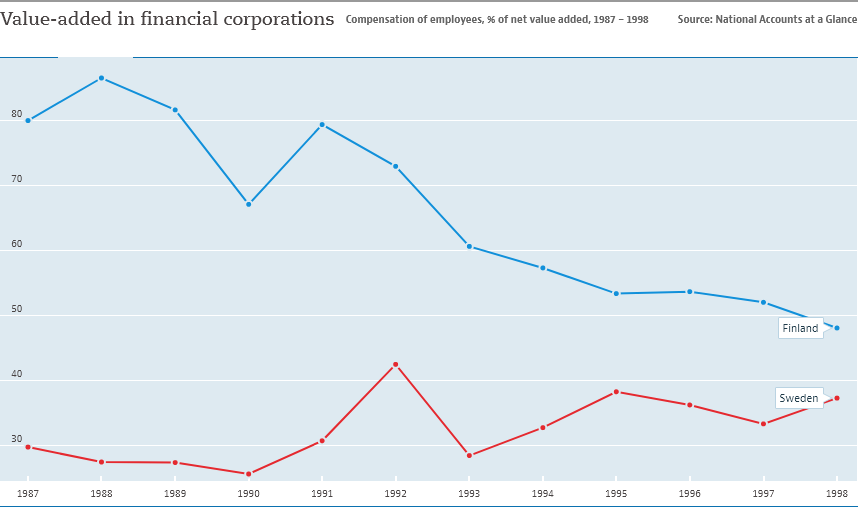Specify some key components in this picture. The value-add in financial corporations was closest between Finland and Sweden in 1998. The value-add in financial corporations in Finland reached its highest level in 1988. 